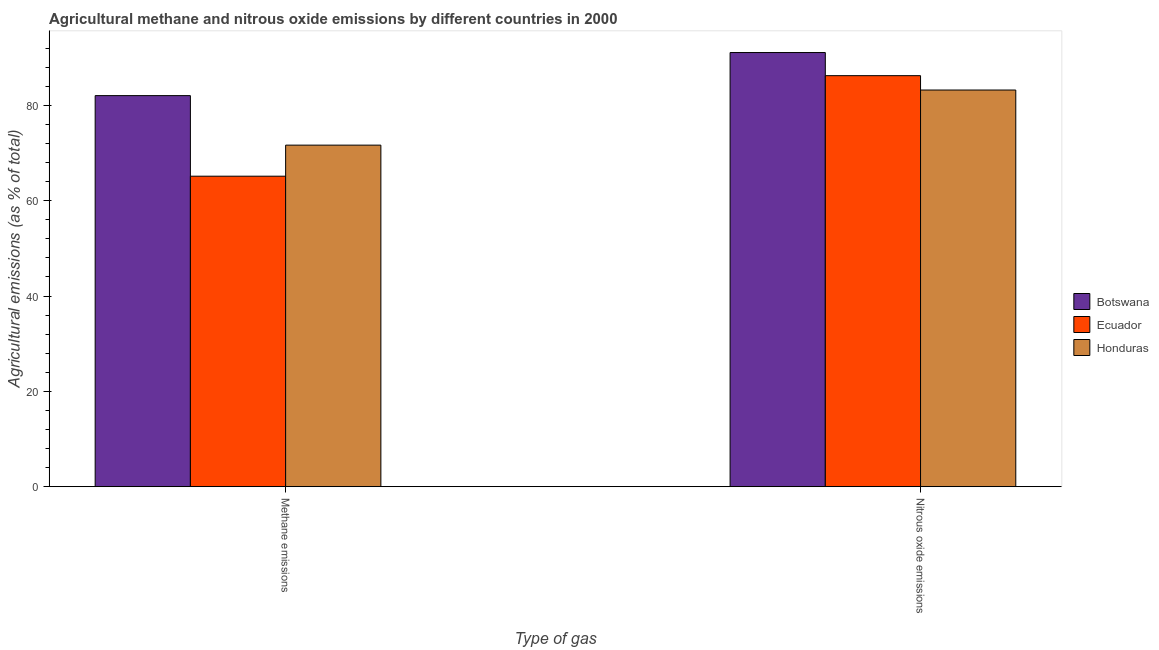How many groups of bars are there?
Provide a succinct answer. 2. Are the number of bars per tick equal to the number of legend labels?
Keep it short and to the point. Yes. How many bars are there on the 1st tick from the left?
Keep it short and to the point. 3. What is the label of the 2nd group of bars from the left?
Ensure brevity in your answer.  Nitrous oxide emissions. What is the amount of methane emissions in Botswana?
Keep it short and to the point. 82.06. Across all countries, what is the maximum amount of nitrous oxide emissions?
Provide a short and direct response. 91.1. Across all countries, what is the minimum amount of methane emissions?
Keep it short and to the point. 65.15. In which country was the amount of nitrous oxide emissions maximum?
Provide a succinct answer. Botswana. In which country was the amount of nitrous oxide emissions minimum?
Provide a short and direct response. Honduras. What is the total amount of nitrous oxide emissions in the graph?
Ensure brevity in your answer.  260.58. What is the difference between the amount of methane emissions in Botswana and that in Honduras?
Offer a very short reply. 10.39. What is the difference between the amount of nitrous oxide emissions in Honduras and the amount of methane emissions in Ecuador?
Keep it short and to the point. 18.08. What is the average amount of methane emissions per country?
Give a very brief answer. 72.96. What is the difference between the amount of methane emissions and amount of nitrous oxide emissions in Botswana?
Give a very brief answer. -9.04. In how many countries, is the amount of nitrous oxide emissions greater than 36 %?
Your response must be concise. 3. What is the ratio of the amount of nitrous oxide emissions in Ecuador to that in Botswana?
Make the answer very short. 0.95. What does the 2nd bar from the left in Methane emissions represents?
Your answer should be very brief. Ecuador. What does the 2nd bar from the right in Methane emissions represents?
Your answer should be very brief. Ecuador. Are all the bars in the graph horizontal?
Provide a short and direct response. No. Does the graph contain any zero values?
Give a very brief answer. No. Where does the legend appear in the graph?
Offer a very short reply. Center right. How many legend labels are there?
Your answer should be very brief. 3. What is the title of the graph?
Keep it short and to the point. Agricultural methane and nitrous oxide emissions by different countries in 2000. What is the label or title of the X-axis?
Provide a succinct answer. Type of gas. What is the label or title of the Y-axis?
Provide a short and direct response. Agricultural emissions (as % of total). What is the Agricultural emissions (as % of total) in Botswana in Methane emissions?
Give a very brief answer. 82.06. What is the Agricultural emissions (as % of total) in Ecuador in Methane emissions?
Your answer should be very brief. 65.15. What is the Agricultural emissions (as % of total) in Honduras in Methane emissions?
Ensure brevity in your answer.  71.67. What is the Agricultural emissions (as % of total) in Botswana in Nitrous oxide emissions?
Provide a succinct answer. 91.1. What is the Agricultural emissions (as % of total) in Ecuador in Nitrous oxide emissions?
Your answer should be very brief. 86.25. What is the Agricultural emissions (as % of total) of Honduras in Nitrous oxide emissions?
Your answer should be compact. 83.23. Across all Type of gas, what is the maximum Agricultural emissions (as % of total) of Botswana?
Your answer should be compact. 91.1. Across all Type of gas, what is the maximum Agricultural emissions (as % of total) in Ecuador?
Make the answer very short. 86.25. Across all Type of gas, what is the maximum Agricultural emissions (as % of total) in Honduras?
Keep it short and to the point. 83.23. Across all Type of gas, what is the minimum Agricultural emissions (as % of total) in Botswana?
Make the answer very short. 82.06. Across all Type of gas, what is the minimum Agricultural emissions (as % of total) in Ecuador?
Your response must be concise. 65.15. Across all Type of gas, what is the minimum Agricultural emissions (as % of total) of Honduras?
Provide a succinct answer. 71.67. What is the total Agricultural emissions (as % of total) of Botswana in the graph?
Make the answer very short. 173.16. What is the total Agricultural emissions (as % of total) of Ecuador in the graph?
Offer a terse response. 151.4. What is the total Agricultural emissions (as % of total) in Honduras in the graph?
Give a very brief answer. 154.9. What is the difference between the Agricultural emissions (as % of total) of Botswana in Methane emissions and that in Nitrous oxide emissions?
Keep it short and to the point. -9.04. What is the difference between the Agricultural emissions (as % of total) in Ecuador in Methane emissions and that in Nitrous oxide emissions?
Make the answer very short. -21.1. What is the difference between the Agricultural emissions (as % of total) of Honduras in Methane emissions and that in Nitrous oxide emissions?
Keep it short and to the point. -11.57. What is the difference between the Agricultural emissions (as % of total) of Botswana in Methane emissions and the Agricultural emissions (as % of total) of Ecuador in Nitrous oxide emissions?
Offer a very short reply. -4.19. What is the difference between the Agricultural emissions (as % of total) of Botswana in Methane emissions and the Agricultural emissions (as % of total) of Honduras in Nitrous oxide emissions?
Your answer should be very brief. -1.18. What is the difference between the Agricultural emissions (as % of total) of Ecuador in Methane emissions and the Agricultural emissions (as % of total) of Honduras in Nitrous oxide emissions?
Keep it short and to the point. -18.08. What is the average Agricultural emissions (as % of total) of Botswana per Type of gas?
Offer a terse response. 86.58. What is the average Agricultural emissions (as % of total) in Ecuador per Type of gas?
Ensure brevity in your answer.  75.7. What is the average Agricultural emissions (as % of total) in Honduras per Type of gas?
Make the answer very short. 77.45. What is the difference between the Agricultural emissions (as % of total) of Botswana and Agricultural emissions (as % of total) of Ecuador in Methane emissions?
Your answer should be very brief. 16.91. What is the difference between the Agricultural emissions (as % of total) in Botswana and Agricultural emissions (as % of total) in Honduras in Methane emissions?
Offer a terse response. 10.39. What is the difference between the Agricultural emissions (as % of total) in Ecuador and Agricultural emissions (as % of total) in Honduras in Methane emissions?
Keep it short and to the point. -6.52. What is the difference between the Agricultural emissions (as % of total) of Botswana and Agricultural emissions (as % of total) of Ecuador in Nitrous oxide emissions?
Your response must be concise. 4.85. What is the difference between the Agricultural emissions (as % of total) in Botswana and Agricultural emissions (as % of total) in Honduras in Nitrous oxide emissions?
Keep it short and to the point. 7.87. What is the difference between the Agricultural emissions (as % of total) of Ecuador and Agricultural emissions (as % of total) of Honduras in Nitrous oxide emissions?
Your answer should be compact. 3.01. What is the ratio of the Agricultural emissions (as % of total) in Botswana in Methane emissions to that in Nitrous oxide emissions?
Make the answer very short. 0.9. What is the ratio of the Agricultural emissions (as % of total) of Ecuador in Methane emissions to that in Nitrous oxide emissions?
Give a very brief answer. 0.76. What is the ratio of the Agricultural emissions (as % of total) of Honduras in Methane emissions to that in Nitrous oxide emissions?
Your answer should be very brief. 0.86. What is the difference between the highest and the second highest Agricultural emissions (as % of total) in Botswana?
Your answer should be compact. 9.04. What is the difference between the highest and the second highest Agricultural emissions (as % of total) in Ecuador?
Offer a very short reply. 21.1. What is the difference between the highest and the second highest Agricultural emissions (as % of total) of Honduras?
Keep it short and to the point. 11.57. What is the difference between the highest and the lowest Agricultural emissions (as % of total) of Botswana?
Your response must be concise. 9.04. What is the difference between the highest and the lowest Agricultural emissions (as % of total) in Ecuador?
Your answer should be compact. 21.1. What is the difference between the highest and the lowest Agricultural emissions (as % of total) of Honduras?
Ensure brevity in your answer.  11.57. 